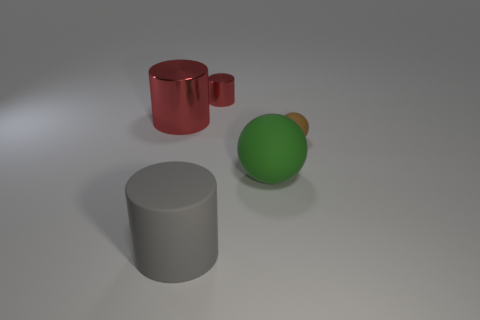Add 1 large green matte spheres. How many objects exist? 6 Subtract all cylinders. How many objects are left? 2 Subtract 0 yellow spheres. How many objects are left? 5 Subtract all big blue rubber cubes. Subtract all small red metal objects. How many objects are left? 4 Add 3 cylinders. How many cylinders are left? 6 Add 1 big brown blocks. How many big brown blocks exist? 1 